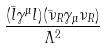<formula> <loc_0><loc_0><loc_500><loc_500>\frac { ( \bar { l } \gamma ^ { \mu } l ) ( \bar { \nu } _ { R } \gamma _ { \mu } \nu _ { R } ) } { \Lambda ^ { 2 } }</formula> 